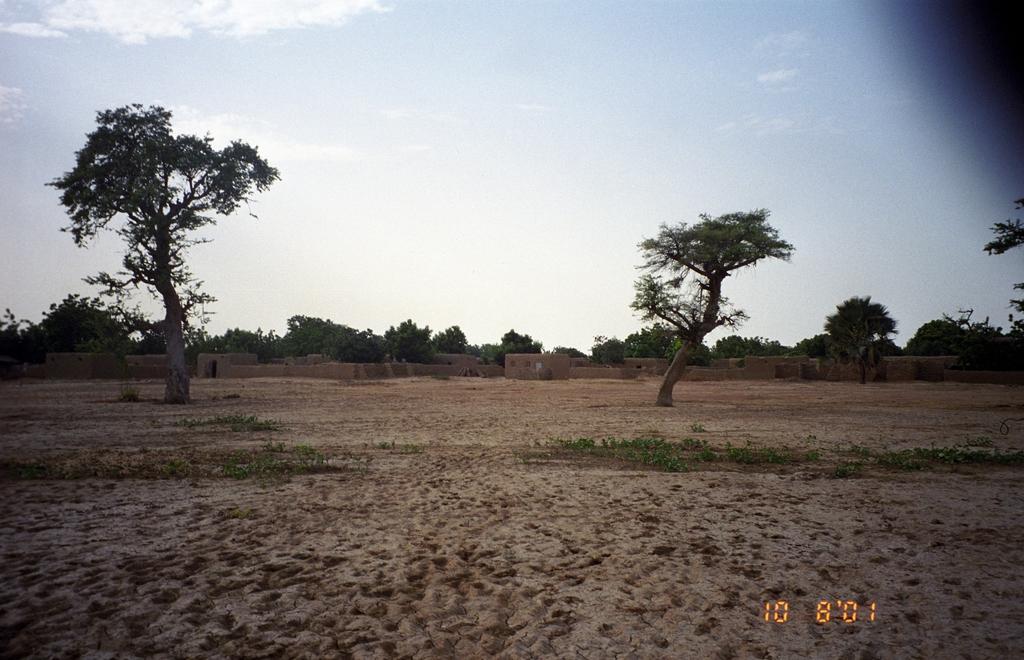Could you give a brief overview of what you see in this image? On the bottom left, there is a watermark. In the background, there are two trees on the dry ground, there is a wall, there are trees and there are clouds in the blue sky. 